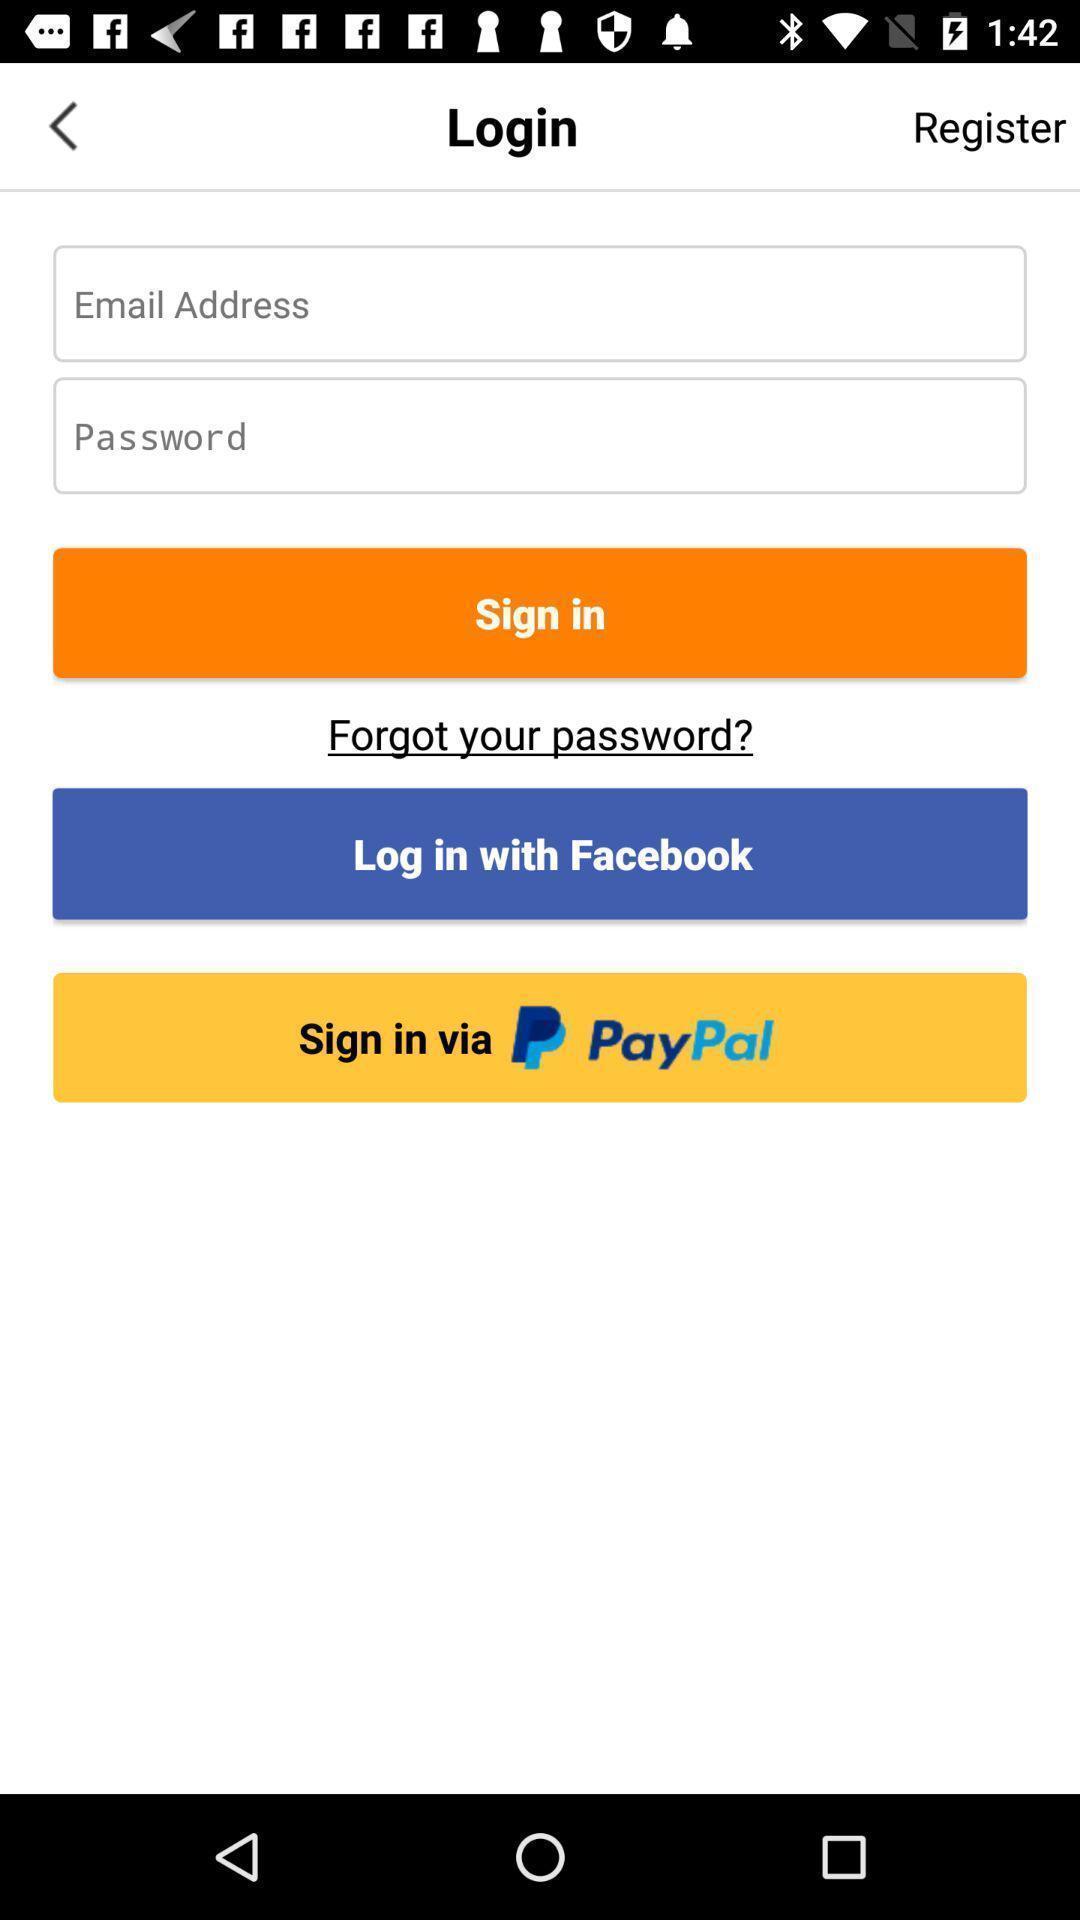Give me a summary of this screen capture. Sign in page. 